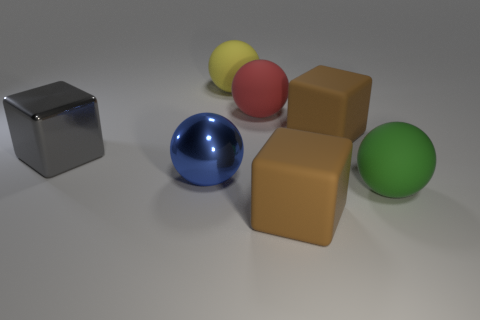Subtract all brown cubes. How many were subtracted if there are1brown cubes left? 1 Subtract all yellow spheres. How many spheres are left? 3 Add 1 red rubber cylinders. How many objects exist? 8 Subtract all red spheres. Subtract all red blocks. How many spheres are left? 3 Subtract all yellow balls. How many purple cubes are left? 0 Subtract all yellow things. Subtract all large yellow rubber balls. How many objects are left? 5 Add 3 large gray shiny things. How many large gray shiny things are left? 4 Add 1 small gray spheres. How many small gray spheres exist? 1 Subtract all yellow spheres. How many spheres are left? 3 Subtract 0 purple cylinders. How many objects are left? 7 